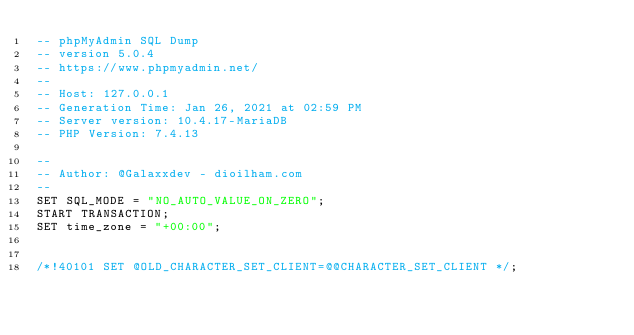Convert code to text. <code><loc_0><loc_0><loc_500><loc_500><_SQL_>-- phpMyAdmin SQL Dump
-- version 5.0.4
-- https://www.phpmyadmin.net/
--
-- Host: 127.0.0.1
-- Generation Time: Jan 26, 2021 at 02:59 PM
-- Server version: 10.4.17-MariaDB
-- PHP Version: 7.4.13

--
-- Author: @Galaxxdev - dioilham.com
--
SET SQL_MODE = "NO_AUTO_VALUE_ON_ZERO";
START TRANSACTION;
SET time_zone = "+00:00";


/*!40101 SET @OLD_CHARACTER_SET_CLIENT=@@CHARACTER_SET_CLIENT */;</code> 